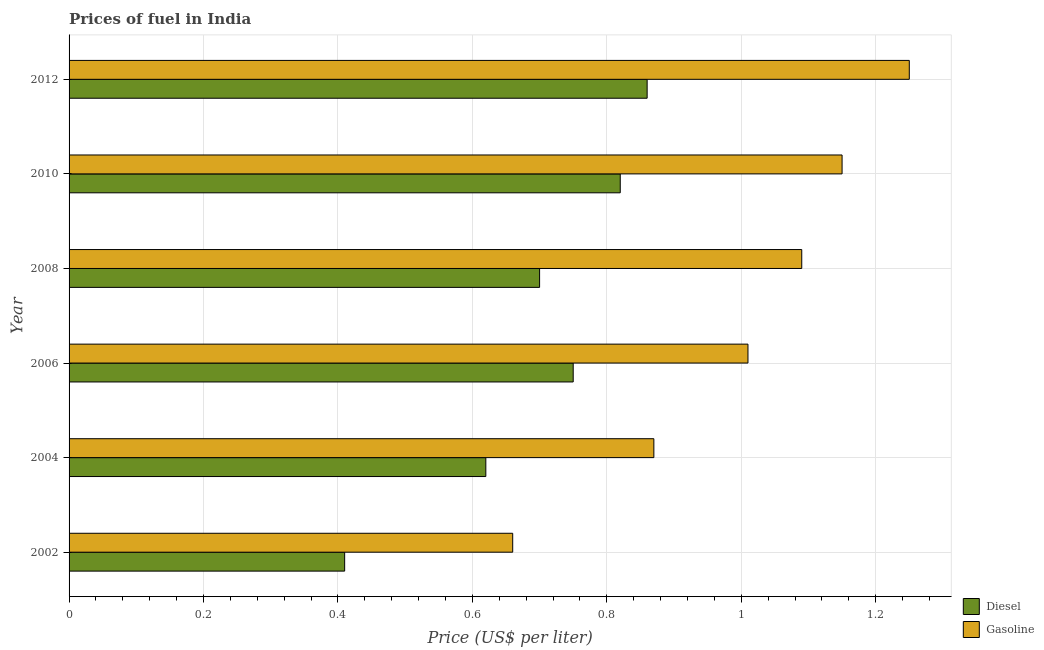How many groups of bars are there?
Provide a short and direct response. 6. Are the number of bars per tick equal to the number of legend labels?
Provide a short and direct response. Yes. How many bars are there on the 5th tick from the top?
Offer a very short reply. 2. How many bars are there on the 3rd tick from the bottom?
Make the answer very short. 2. What is the label of the 4th group of bars from the top?
Ensure brevity in your answer.  2006. What is the diesel price in 2010?
Offer a terse response. 0.82. Across all years, what is the maximum diesel price?
Offer a very short reply. 0.86. Across all years, what is the minimum diesel price?
Make the answer very short. 0.41. In which year was the gasoline price maximum?
Provide a succinct answer. 2012. What is the total diesel price in the graph?
Your answer should be very brief. 4.16. What is the difference between the gasoline price in 2004 and that in 2008?
Give a very brief answer. -0.22. What is the difference between the diesel price in 2006 and the gasoline price in 2002?
Offer a terse response. 0.09. In the year 2010, what is the difference between the diesel price and gasoline price?
Your response must be concise. -0.33. What is the ratio of the gasoline price in 2004 to that in 2006?
Offer a very short reply. 0.86. Is the gasoline price in 2002 less than that in 2004?
Your answer should be very brief. Yes. Is the difference between the gasoline price in 2010 and 2012 greater than the difference between the diesel price in 2010 and 2012?
Your answer should be compact. No. What is the difference between the highest and the lowest diesel price?
Provide a short and direct response. 0.45. In how many years, is the gasoline price greater than the average gasoline price taken over all years?
Your response must be concise. 4. Is the sum of the gasoline price in 2002 and 2006 greater than the maximum diesel price across all years?
Offer a terse response. Yes. What does the 1st bar from the top in 2012 represents?
Your answer should be very brief. Gasoline. What does the 2nd bar from the bottom in 2004 represents?
Ensure brevity in your answer.  Gasoline. How many bars are there?
Keep it short and to the point. 12. Are all the bars in the graph horizontal?
Give a very brief answer. Yes. What is the difference between two consecutive major ticks on the X-axis?
Provide a short and direct response. 0.2. Are the values on the major ticks of X-axis written in scientific E-notation?
Provide a short and direct response. No. Where does the legend appear in the graph?
Give a very brief answer. Bottom right. How are the legend labels stacked?
Provide a succinct answer. Vertical. What is the title of the graph?
Your answer should be compact. Prices of fuel in India. Does "Secondary Education" appear as one of the legend labels in the graph?
Provide a succinct answer. No. What is the label or title of the X-axis?
Your answer should be very brief. Price (US$ per liter). What is the Price (US$ per liter) in Diesel in 2002?
Give a very brief answer. 0.41. What is the Price (US$ per liter) in Gasoline in 2002?
Keep it short and to the point. 0.66. What is the Price (US$ per liter) of Diesel in 2004?
Your answer should be very brief. 0.62. What is the Price (US$ per liter) of Gasoline in 2004?
Ensure brevity in your answer.  0.87. What is the Price (US$ per liter) of Diesel in 2006?
Offer a very short reply. 0.75. What is the Price (US$ per liter) of Diesel in 2008?
Give a very brief answer. 0.7. What is the Price (US$ per liter) of Gasoline in 2008?
Keep it short and to the point. 1.09. What is the Price (US$ per liter) of Diesel in 2010?
Your answer should be very brief. 0.82. What is the Price (US$ per liter) in Gasoline in 2010?
Ensure brevity in your answer.  1.15. What is the Price (US$ per liter) of Diesel in 2012?
Your answer should be compact. 0.86. What is the Price (US$ per liter) of Gasoline in 2012?
Your answer should be compact. 1.25. Across all years, what is the maximum Price (US$ per liter) of Diesel?
Give a very brief answer. 0.86. Across all years, what is the minimum Price (US$ per liter) in Diesel?
Your answer should be compact. 0.41. Across all years, what is the minimum Price (US$ per liter) of Gasoline?
Your answer should be compact. 0.66. What is the total Price (US$ per liter) in Diesel in the graph?
Give a very brief answer. 4.16. What is the total Price (US$ per liter) in Gasoline in the graph?
Offer a terse response. 6.03. What is the difference between the Price (US$ per liter) of Diesel in 2002 and that in 2004?
Keep it short and to the point. -0.21. What is the difference between the Price (US$ per liter) in Gasoline in 2002 and that in 2004?
Ensure brevity in your answer.  -0.21. What is the difference between the Price (US$ per liter) in Diesel in 2002 and that in 2006?
Your answer should be compact. -0.34. What is the difference between the Price (US$ per liter) in Gasoline in 2002 and that in 2006?
Your answer should be compact. -0.35. What is the difference between the Price (US$ per liter) in Diesel in 2002 and that in 2008?
Your response must be concise. -0.29. What is the difference between the Price (US$ per liter) of Gasoline in 2002 and that in 2008?
Give a very brief answer. -0.43. What is the difference between the Price (US$ per liter) in Diesel in 2002 and that in 2010?
Provide a short and direct response. -0.41. What is the difference between the Price (US$ per liter) of Gasoline in 2002 and that in 2010?
Give a very brief answer. -0.49. What is the difference between the Price (US$ per liter) of Diesel in 2002 and that in 2012?
Keep it short and to the point. -0.45. What is the difference between the Price (US$ per liter) in Gasoline in 2002 and that in 2012?
Keep it short and to the point. -0.59. What is the difference between the Price (US$ per liter) of Diesel in 2004 and that in 2006?
Keep it short and to the point. -0.13. What is the difference between the Price (US$ per liter) in Gasoline in 2004 and that in 2006?
Ensure brevity in your answer.  -0.14. What is the difference between the Price (US$ per liter) of Diesel in 2004 and that in 2008?
Keep it short and to the point. -0.08. What is the difference between the Price (US$ per liter) of Gasoline in 2004 and that in 2008?
Your response must be concise. -0.22. What is the difference between the Price (US$ per liter) of Gasoline in 2004 and that in 2010?
Your answer should be compact. -0.28. What is the difference between the Price (US$ per liter) in Diesel in 2004 and that in 2012?
Ensure brevity in your answer.  -0.24. What is the difference between the Price (US$ per liter) in Gasoline in 2004 and that in 2012?
Offer a terse response. -0.38. What is the difference between the Price (US$ per liter) of Diesel in 2006 and that in 2008?
Ensure brevity in your answer.  0.05. What is the difference between the Price (US$ per liter) of Gasoline in 2006 and that in 2008?
Make the answer very short. -0.08. What is the difference between the Price (US$ per liter) of Diesel in 2006 and that in 2010?
Provide a succinct answer. -0.07. What is the difference between the Price (US$ per liter) of Gasoline in 2006 and that in 2010?
Make the answer very short. -0.14. What is the difference between the Price (US$ per liter) of Diesel in 2006 and that in 2012?
Offer a terse response. -0.11. What is the difference between the Price (US$ per liter) of Gasoline in 2006 and that in 2012?
Keep it short and to the point. -0.24. What is the difference between the Price (US$ per liter) of Diesel in 2008 and that in 2010?
Offer a terse response. -0.12. What is the difference between the Price (US$ per liter) of Gasoline in 2008 and that in 2010?
Your response must be concise. -0.06. What is the difference between the Price (US$ per liter) of Diesel in 2008 and that in 2012?
Keep it short and to the point. -0.16. What is the difference between the Price (US$ per liter) of Gasoline in 2008 and that in 2012?
Your answer should be compact. -0.16. What is the difference between the Price (US$ per liter) of Diesel in 2010 and that in 2012?
Make the answer very short. -0.04. What is the difference between the Price (US$ per liter) in Diesel in 2002 and the Price (US$ per liter) in Gasoline in 2004?
Give a very brief answer. -0.46. What is the difference between the Price (US$ per liter) in Diesel in 2002 and the Price (US$ per liter) in Gasoline in 2008?
Offer a very short reply. -0.68. What is the difference between the Price (US$ per liter) in Diesel in 2002 and the Price (US$ per liter) in Gasoline in 2010?
Offer a terse response. -0.74. What is the difference between the Price (US$ per liter) of Diesel in 2002 and the Price (US$ per liter) of Gasoline in 2012?
Provide a succinct answer. -0.84. What is the difference between the Price (US$ per liter) in Diesel in 2004 and the Price (US$ per liter) in Gasoline in 2006?
Offer a terse response. -0.39. What is the difference between the Price (US$ per liter) in Diesel in 2004 and the Price (US$ per liter) in Gasoline in 2008?
Give a very brief answer. -0.47. What is the difference between the Price (US$ per liter) in Diesel in 2004 and the Price (US$ per liter) in Gasoline in 2010?
Offer a terse response. -0.53. What is the difference between the Price (US$ per liter) in Diesel in 2004 and the Price (US$ per liter) in Gasoline in 2012?
Provide a short and direct response. -0.63. What is the difference between the Price (US$ per liter) in Diesel in 2006 and the Price (US$ per liter) in Gasoline in 2008?
Your answer should be very brief. -0.34. What is the difference between the Price (US$ per liter) of Diesel in 2006 and the Price (US$ per liter) of Gasoline in 2010?
Provide a succinct answer. -0.4. What is the difference between the Price (US$ per liter) in Diesel in 2006 and the Price (US$ per liter) in Gasoline in 2012?
Keep it short and to the point. -0.5. What is the difference between the Price (US$ per liter) in Diesel in 2008 and the Price (US$ per liter) in Gasoline in 2010?
Keep it short and to the point. -0.45. What is the difference between the Price (US$ per liter) in Diesel in 2008 and the Price (US$ per liter) in Gasoline in 2012?
Keep it short and to the point. -0.55. What is the difference between the Price (US$ per liter) of Diesel in 2010 and the Price (US$ per liter) of Gasoline in 2012?
Give a very brief answer. -0.43. What is the average Price (US$ per liter) in Diesel per year?
Make the answer very short. 0.69. In the year 2004, what is the difference between the Price (US$ per liter) in Diesel and Price (US$ per liter) in Gasoline?
Give a very brief answer. -0.25. In the year 2006, what is the difference between the Price (US$ per liter) of Diesel and Price (US$ per liter) of Gasoline?
Ensure brevity in your answer.  -0.26. In the year 2008, what is the difference between the Price (US$ per liter) of Diesel and Price (US$ per liter) of Gasoline?
Keep it short and to the point. -0.39. In the year 2010, what is the difference between the Price (US$ per liter) in Diesel and Price (US$ per liter) in Gasoline?
Make the answer very short. -0.33. In the year 2012, what is the difference between the Price (US$ per liter) of Diesel and Price (US$ per liter) of Gasoline?
Give a very brief answer. -0.39. What is the ratio of the Price (US$ per liter) of Diesel in 2002 to that in 2004?
Provide a short and direct response. 0.66. What is the ratio of the Price (US$ per liter) of Gasoline in 2002 to that in 2004?
Your response must be concise. 0.76. What is the ratio of the Price (US$ per liter) of Diesel in 2002 to that in 2006?
Make the answer very short. 0.55. What is the ratio of the Price (US$ per liter) in Gasoline in 2002 to that in 2006?
Make the answer very short. 0.65. What is the ratio of the Price (US$ per liter) in Diesel in 2002 to that in 2008?
Make the answer very short. 0.59. What is the ratio of the Price (US$ per liter) of Gasoline in 2002 to that in 2008?
Provide a short and direct response. 0.61. What is the ratio of the Price (US$ per liter) in Diesel in 2002 to that in 2010?
Your response must be concise. 0.5. What is the ratio of the Price (US$ per liter) of Gasoline in 2002 to that in 2010?
Provide a short and direct response. 0.57. What is the ratio of the Price (US$ per liter) in Diesel in 2002 to that in 2012?
Offer a very short reply. 0.48. What is the ratio of the Price (US$ per liter) in Gasoline in 2002 to that in 2012?
Provide a succinct answer. 0.53. What is the ratio of the Price (US$ per liter) in Diesel in 2004 to that in 2006?
Make the answer very short. 0.83. What is the ratio of the Price (US$ per liter) of Gasoline in 2004 to that in 2006?
Give a very brief answer. 0.86. What is the ratio of the Price (US$ per liter) in Diesel in 2004 to that in 2008?
Keep it short and to the point. 0.89. What is the ratio of the Price (US$ per liter) in Gasoline in 2004 to that in 2008?
Offer a terse response. 0.8. What is the ratio of the Price (US$ per liter) in Diesel in 2004 to that in 2010?
Provide a short and direct response. 0.76. What is the ratio of the Price (US$ per liter) in Gasoline in 2004 to that in 2010?
Ensure brevity in your answer.  0.76. What is the ratio of the Price (US$ per liter) of Diesel in 2004 to that in 2012?
Provide a short and direct response. 0.72. What is the ratio of the Price (US$ per liter) in Gasoline in 2004 to that in 2012?
Give a very brief answer. 0.7. What is the ratio of the Price (US$ per liter) in Diesel in 2006 to that in 2008?
Your response must be concise. 1.07. What is the ratio of the Price (US$ per liter) in Gasoline in 2006 to that in 2008?
Offer a very short reply. 0.93. What is the ratio of the Price (US$ per liter) in Diesel in 2006 to that in 2010?
Offer a very short reply. 0.91. What is the ratio of the Price (US$ per liter) in Gasoline in 2006 to that in 2010?
Provide a succinct answer. 0.88. What is the ratio of the Price (US$ per liter) in Diesel in 2006 to that in 2012?
Offer a terse response. 0.87. What is the ratio of the Price (US$ per liter) of Gasoline in 2006 to that in 2012?
Your answer should be compact. 0.81. What is the ratio of the Price (US$ per liter) of Diesel in 2008 to that in 2010?
Provide a short and direct response. 0.85. What is the ratio of the Price (US$ per liter) of Gasoline in 2008 to that in 2010?
Offer a very short reply. 0.95. What is the ratio of the Price (US$ per liter) of Diesel in 2008 to that in 2012?
Your answer should be compact. 0.81. What is the ratio of the Price (US$ per liter) of Gasoline in 2008 to that in 2012?
Offer a very short reply. 0.87. What is the ratio of the Price (US$ per liter) of Diesel in 2010 to that in 2012?
Provide a short and direct response. 0.95. What is the difference between the highest and the second highest Price (US$ per liter) of Diesel?
Your response must be concise. 0.04. What is the difference between the highest and the second highest Price (US$ per liter) in Gasoline?
Provide a succinct answer. 0.1. What is the difference between the highest and the lowest Price (US$ per liter) in Diesel?
Your answer should be compact. 0.45. What is the difference between the highest and the lowest Price (US$ per liter) of Gasoline?
Your answer should be compact. 0.59. 